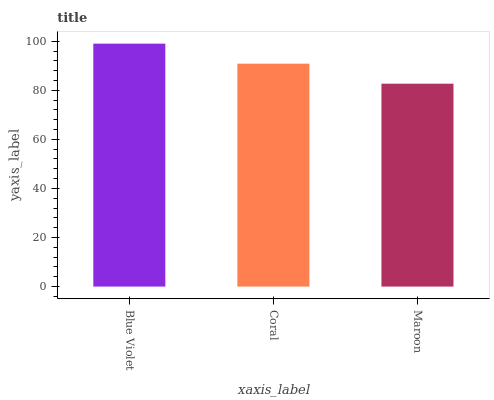Is Maroon the minimum?
Answer yes or no. Yes. Is Blue Violet the maximum?
Answer yes or no. Yes. Is Coral the minimum?
Answer yes or no. No. Is Coral the maximum?
Answer yes or no. No. Is Blue Violet greater than Coral?
Answer yes or no. Yes. Is Coral less than Blue Violet?
Answer yes or no. Yes. Is Coral greater than Blue Violet?
Answer yes or no. No. Is Blue Violet less than Coral?
Answer yes or no. No. Is Coral the high median?
Answer yes or no. Yes. Is Coral the low median?
Answer yes or no. Yes. Is Blue Violet the high median?
Answer yes or no. No. Is Blue Violet the low median?
Answer yes or no. No. 